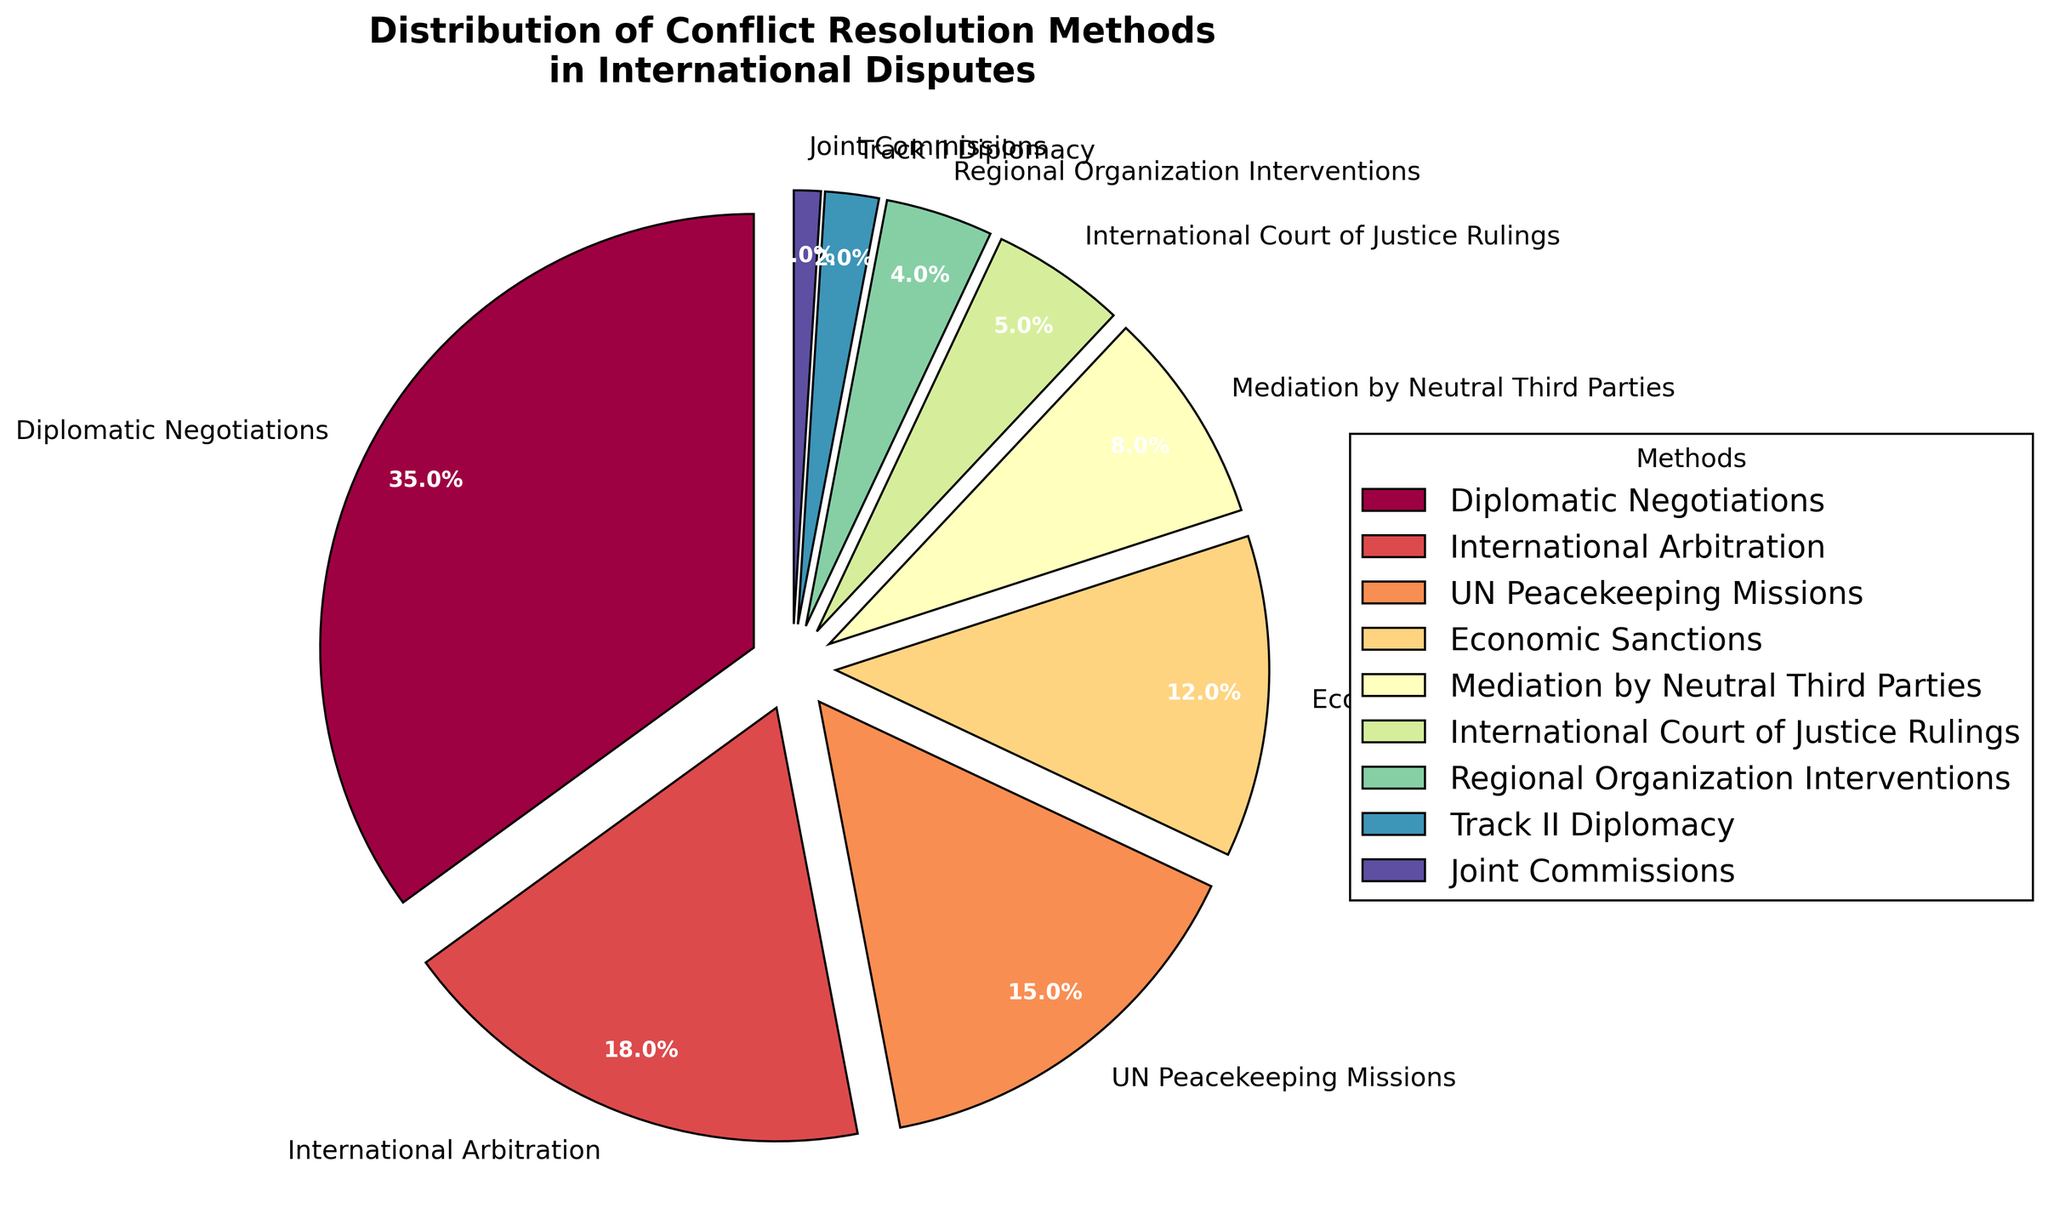What method is used the most for conflict resolution? To determine the method used the most, look for the one with the largest percentage in the figure. Diplomatic Negotiations have the highest percentage.
Answer: Diplomatic Negotiations Which two methods combined have the smallest percentage? Find two methods with the smallest individual percentages and add them. Track II Diplomacy (2%) and Joint Commissions (1%) together make 3%.
Answer: Track II Diplomacy and Joint Commissions How many methods have a percentage greater than 10%? Count the number of methods with percentages larger than 10%. Diplomatic Negotiations (35%), International Arbitration (18%), UN Peacekeeping Missions (15%), and Economic Sanctions (12%) are four methods exceeding 10%.
Answer: 4 What percentage of methods account for economic interventions (sum of Economic Sanctions and Economic Mediation by Neutral Third Parties)? Add the percentages of Economic Sanctions (12%) and Mediation by Neutral Third Parties (8%). The total is 20%.
Answer: 20% Which method has the smallest representation, and what is its percentage? Find the method with the smallest percentage in the pie chart. Joint Commissions have the smallest percentage with 1%.
Answer: Joint Commissions (1%) Are there more methods that use judicial processes (International Court of Justice Rulings) or informal negotiations (Track II Diplomacy and Joint Commissions combined)? Compare the percentage of International Court of Justice Rulings (5%) with the sum of Track II Diplomacy (2%) and Joint Commissions (1%), which equals 3%. Judicial processes have a higher percentage.
Answer: Judicial processes Which method, other than Diplomatic Negotiations, has the highest percentage? Exclude Diplomatic Negotiations and compare the percentages of the remaining methods. International Arbitration has the highest percentage among the remaining methods.
Answer: International Arbitration What is the combined percentage of methods falling under UN and regional organizations' interventions? Add the percentages of UN Peacekeeping Missions (15%) and Regional Organization Interventions (4%). The total is 19%.
Answer: 19% What is the difference in percentage between the most and least used methods? Subtract the percentage of the least used method (Joint Commissions, 1%) from the most used method (Diplomatic Negotiations, 35%). The difference is 34%.
Answer: 34% What is the approximate average percentage of all the methods? Sum all percentages and divide by the number of methods. The total percentage is 100%, and there are 9 methods, so the average is 100/9, which is approximately 11.1%.
Answer: Approximately 11.1% 